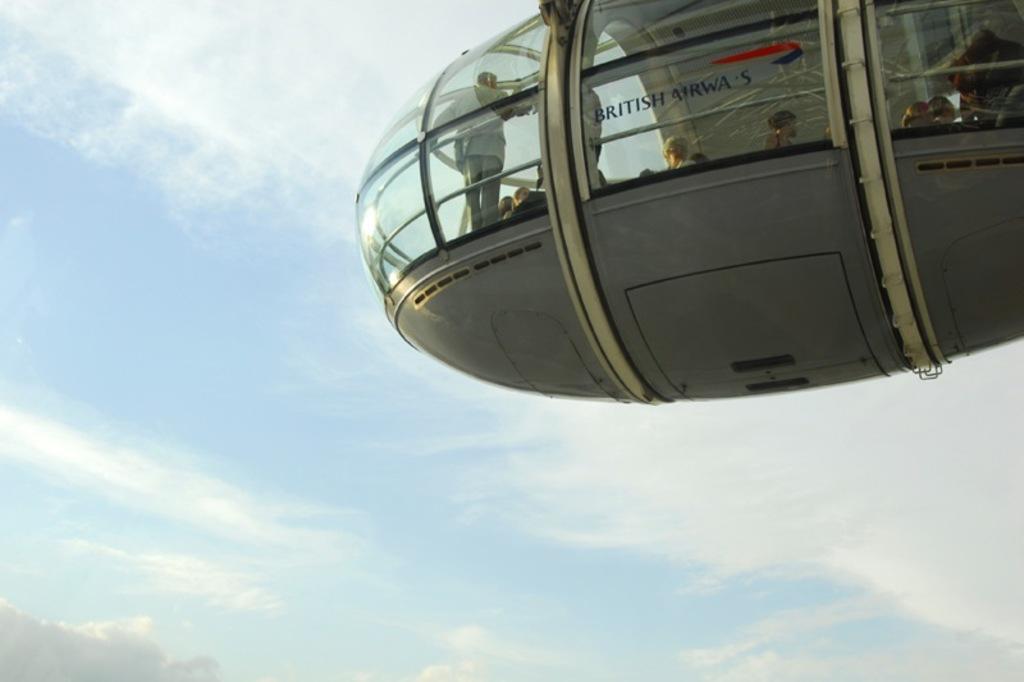Please provide a concise description of this image. In the foreground of this image, on the top, it seems like a cable car and persons are inside it. In the background, there is the sky and the cloud. 